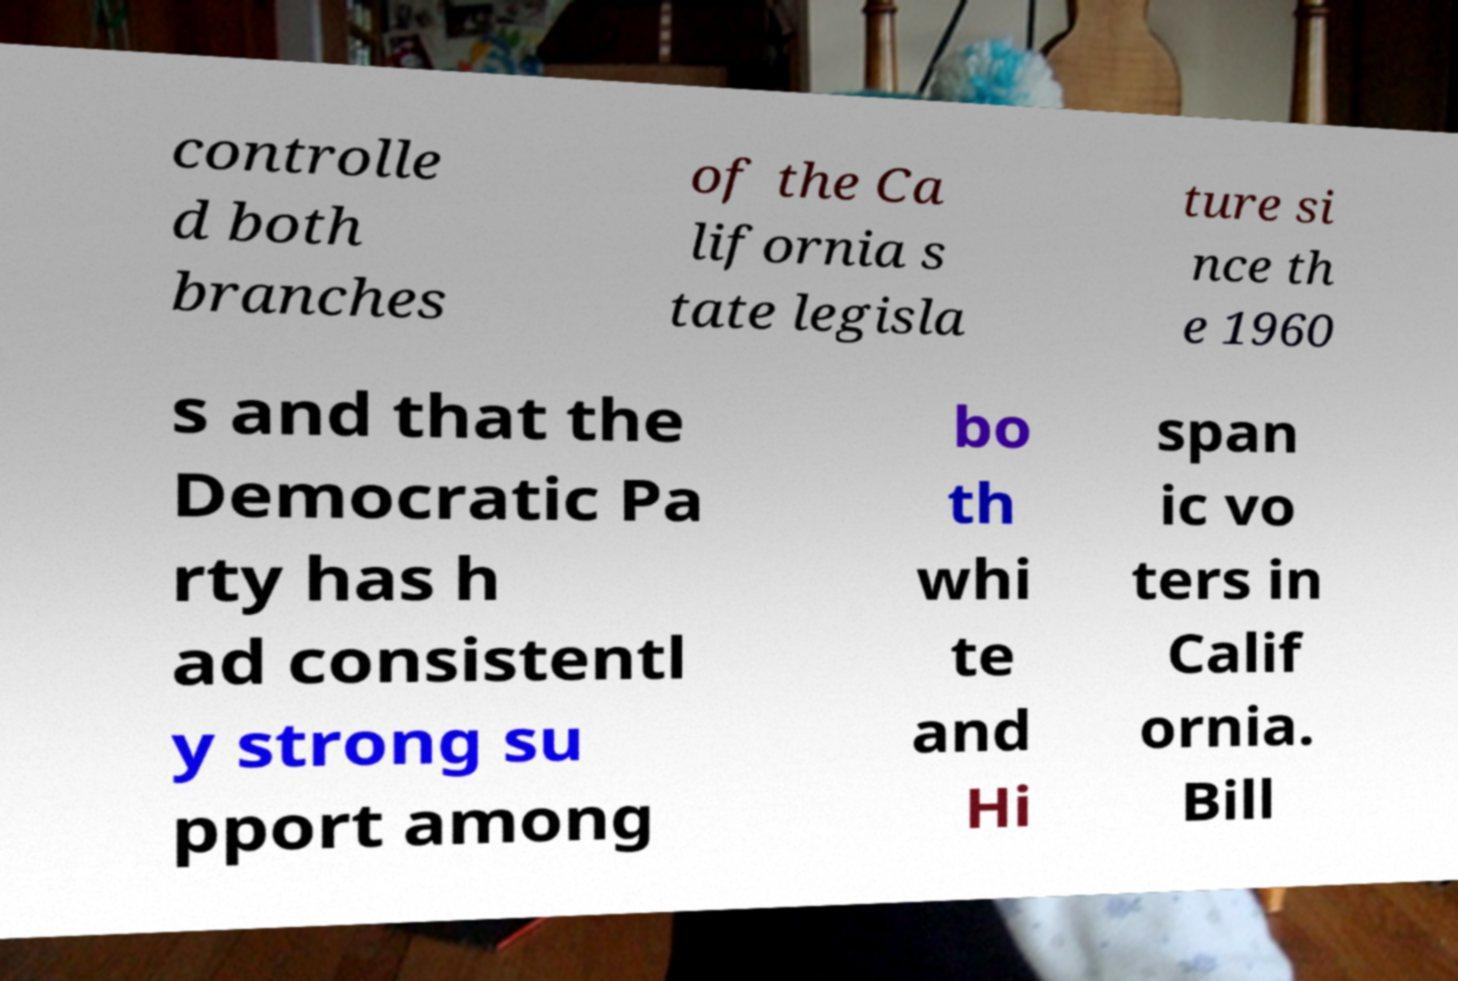Could you assist in decoding the text presented in this image and type it out clearly? controlle d both branches of the Ca lifornia s tate legisla ture si nce th e 1960 s and that the Democratic Pa rty has h ad consistentl y strong su pport among bo th whi te and Hi span ic vo ters in Calif ornia. Bill 